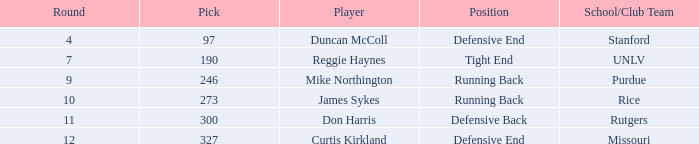What is the highest round number for the player who came from team Missouri? 12.0. 